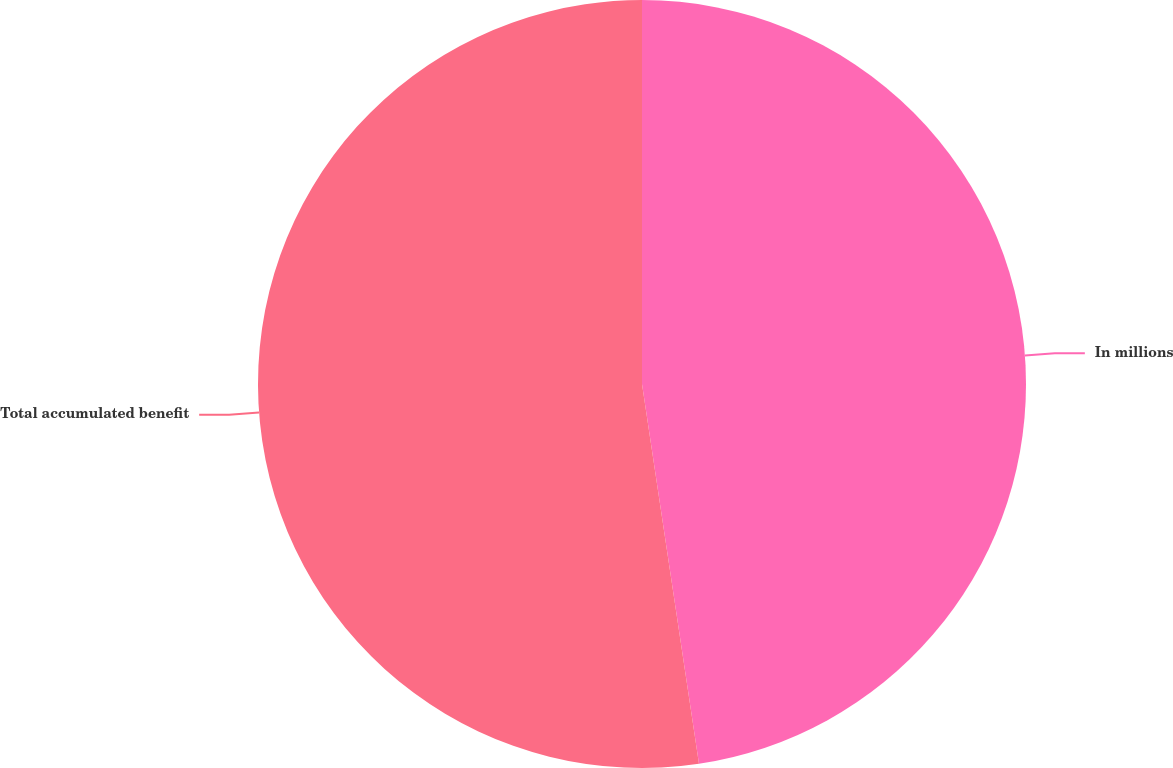Convert chart to OTSL. <chart><loc_0><loc_0><loc_500><loc_500><pie_chart><fcel>In millions<fcel>Total accumulated benefit<nl><fcel>47.63%<fcel>52.37%<nl></chart> 